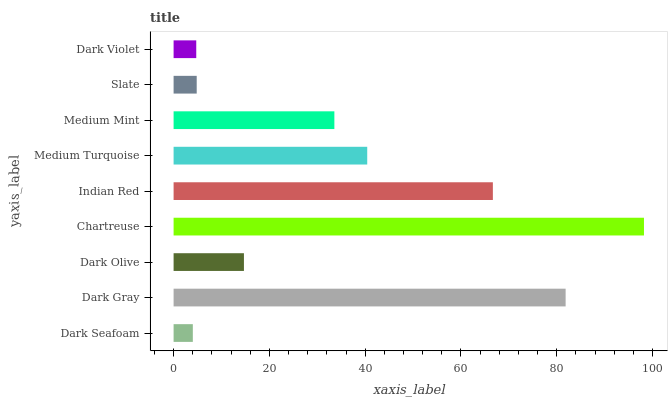Is Dark Seafoam the minimum?
Answer yes or no. Yes. Is Chartreuse the maximum?
Answer yes or no. Yes. Is Dark Gray the minimum?
Answer yes or no. No. Is Dark Gray the maximum?
Answer yes or no. No. Is Dark Gray greater than Dark Seafoam?
Answer yes or no. Yes. Is Dark Seafoam less than Dark Gray?
Answer yes or no. Yes. Is Dark Seafoam greater than Dark Gray?
Answer yes or no. No. Is Dark Gray less than Dark Seafoam?
Answer yes or no. No. Is Medium Mint the high median?
Answer yes or no. Yes. Is Medium Mint the low median?
Answer yes or no. Yes. Is Dark Violet the high median?
Answer yes or no. No. Is Dark Seafoam the low median?
Answer yes or no. No. 